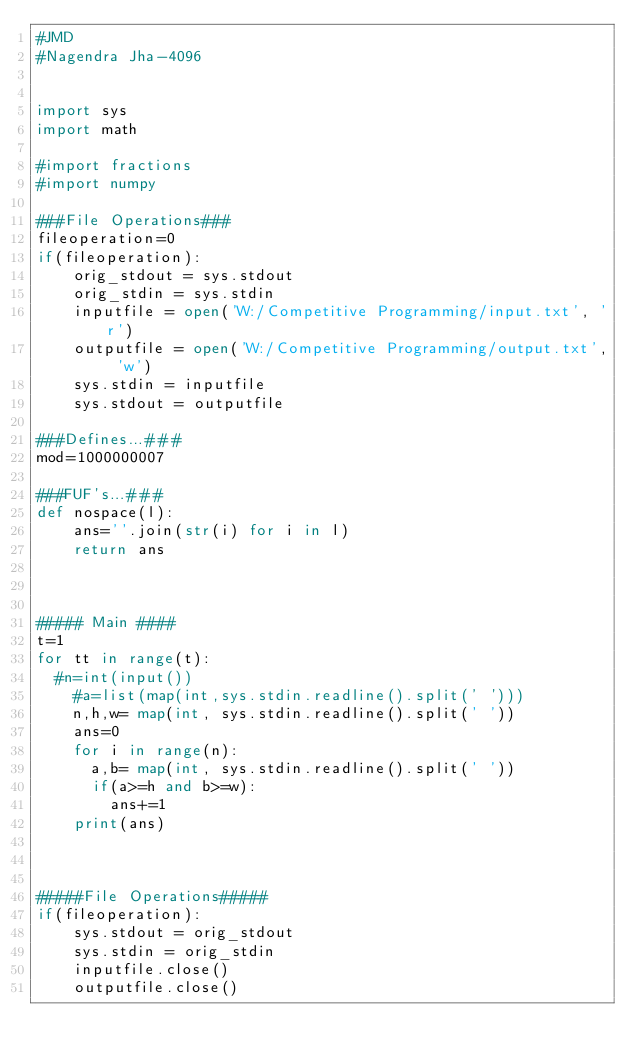<code> <loc_0><loc_0><loc_500><loc_500><_Python_>#JMD
#Nagendra Jha-4096

 
import sys
import math

#import fractions
#import numpy
 
###File Operations###
fileoperation=0
if(fileoperation):
    orig_stdout = sys.stdout
    orig_stdin = sys.stdin
    inputfile = open('W:/Competitive Programming/input.txt', 'r')
    outputfile = open('W:/Competitive Programming/output.txt', 'w')
    sys.stdin = inputfile
    sys.stdout = outputfile

###Defines...###
mod=1000000007
 
###FUF's...###
def nospace(l):
    ans=''.join(str(i) for i in l)
    return ans
 
 
 
##### Main ####
t=1
for tt in range(t):
	#n=int(input())
    #a=list(map(int,sys.stdin.readline().split(' ')))
    n,h,w= map(int, sys.stdin.readline().split(' '))
    ans=0
    for i in range(n):
    	a,b= map(int, sys.stdin.readline().split(' '))
    	if(a>=h and b>=w):
    		ans+=1
    print(ans)

    
    
#####File Operations#####
if(fileoperation):
    sys.stdout = orig_stdout
    sys.stdin = orig_stdin
    inputfile.close()
    outputfile.close()</code> 